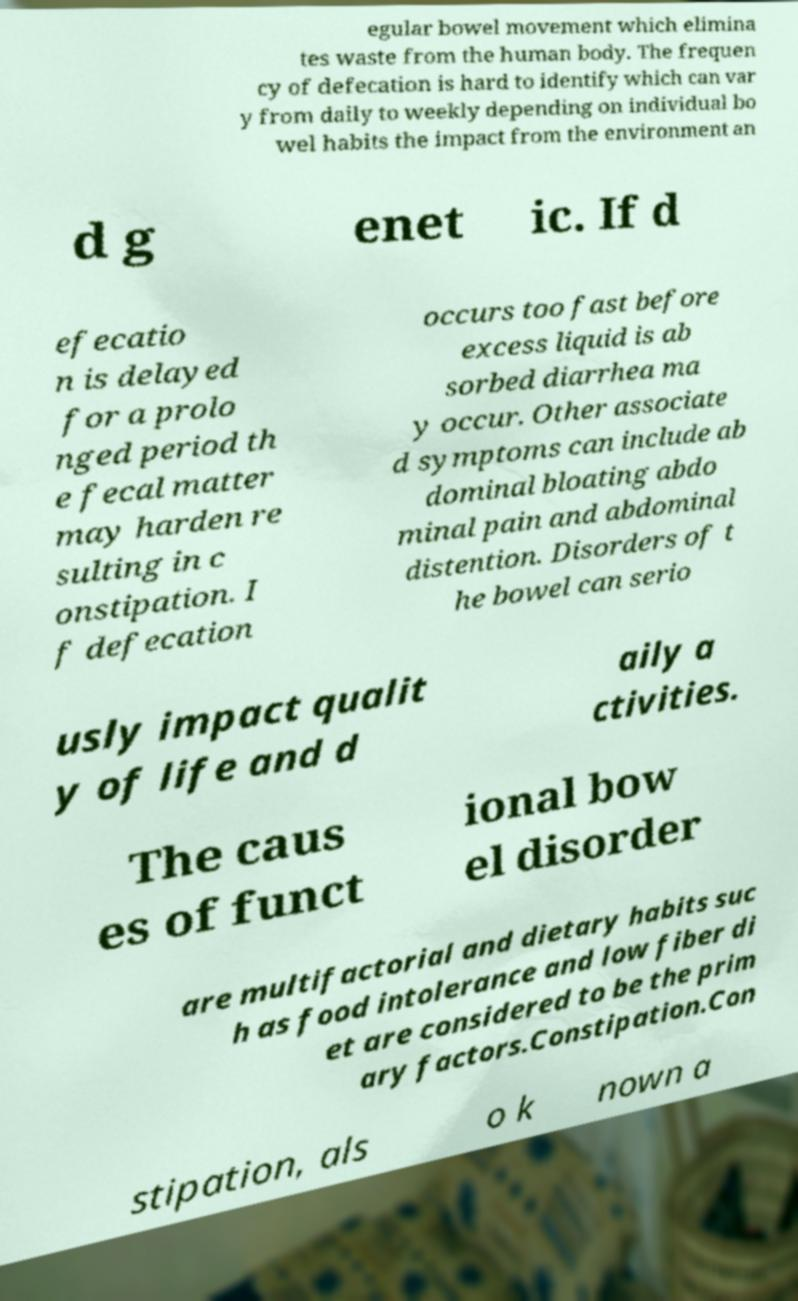Could you extract and type out the text from this image? egular bowel movement which elimina tes waste from the human body. The frequen cy of defecation is hard to identify which can var y from daily to weekly depending on individual bo wel habits the impact from the environment an d g enet ic. If d efecatio n is delayed for a prolo nged period th e fecal matter may harden re sulting in c onstipation. I f defecation occurs too fast before excess liquid is ab sorbed diarrhea ma y occur. Other associate d symptoms can include ab dominal bloating abdo minal pain and abdominal distention. Disorders of t he bowel can serio usly impact qualit y of life and d aily a ctivities. The caus es of funct ional bow el disorder are multifactorial and dietary habits suc h as food intolerance and low fiber di et are considered to be the prim ary factors.Constipation.Con stipation, als o k nown a 